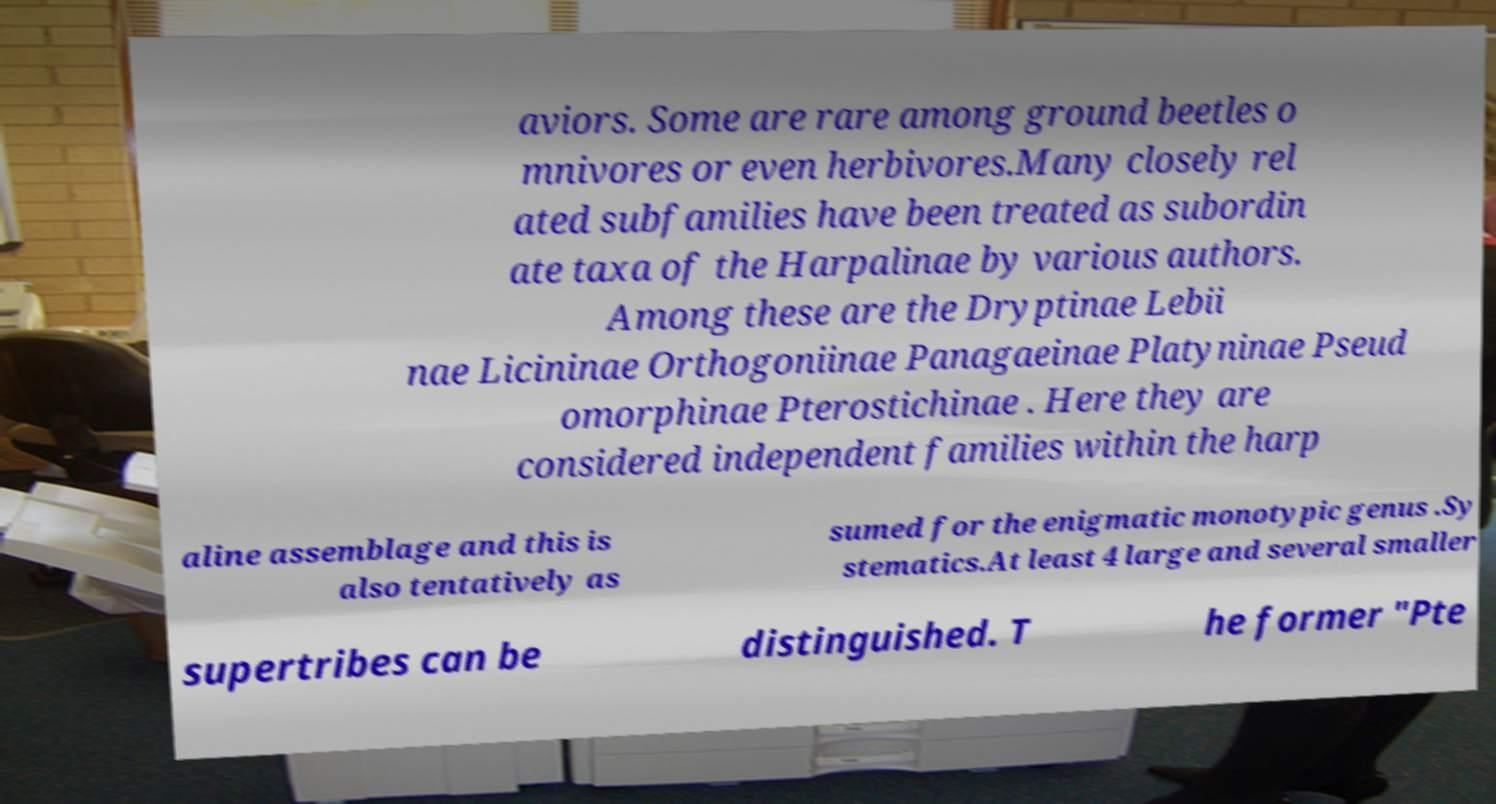Could you extract and type out the text from this image? aviors. Some are rare among ground beetles o mnivores or even herbivores.Many closely rel ated subfamilies have been treated as subordin ate taxa of the Harpalinae by various authors. Among these are the Dryptinae Lebii nae Licininae Orthogoniinae Panagaeinae Platyninae Pseud omorphinae Pterostichinae . Here they are considered independent families within the harp aline assemblage and this is also tentatively as sumed for the enigmatic monotypic genus .Sy stematics.At least 4 large and several smaller supertribes can be distinguished. T he former "Pte 